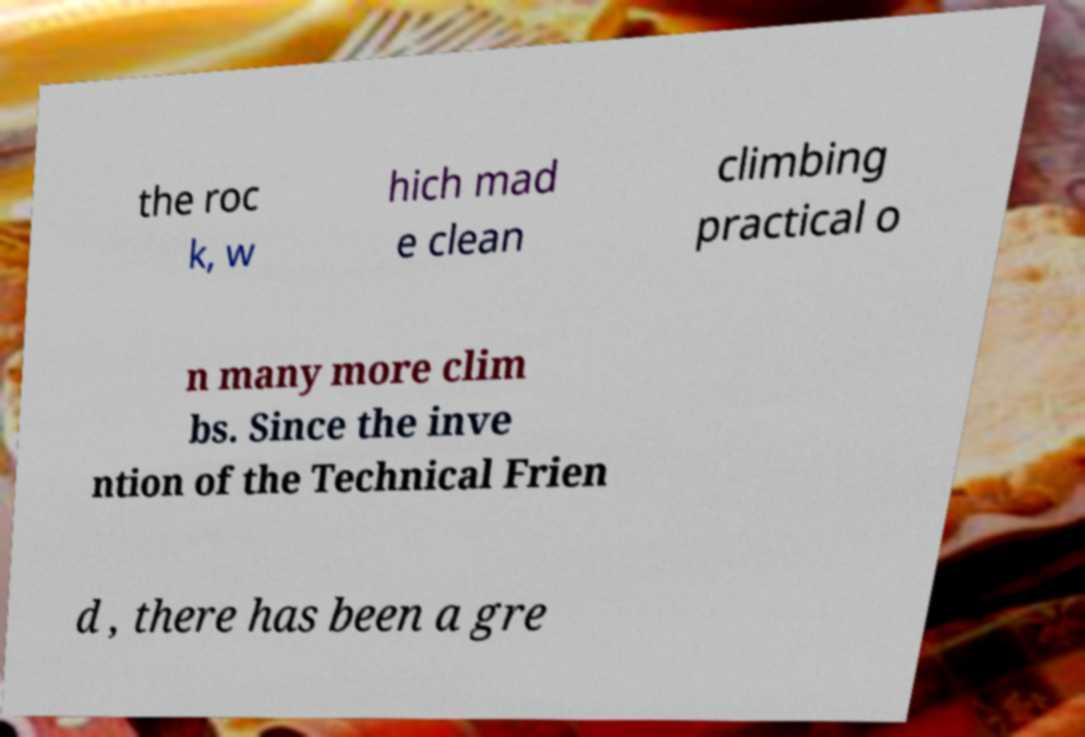Could you assist in decoding the text presented in this image and type it out clearly? the roc k, w hich mad e clean climbing practical o n many more clim bs. Since the inve ntion of the Technical Frien d , there has been a gre 